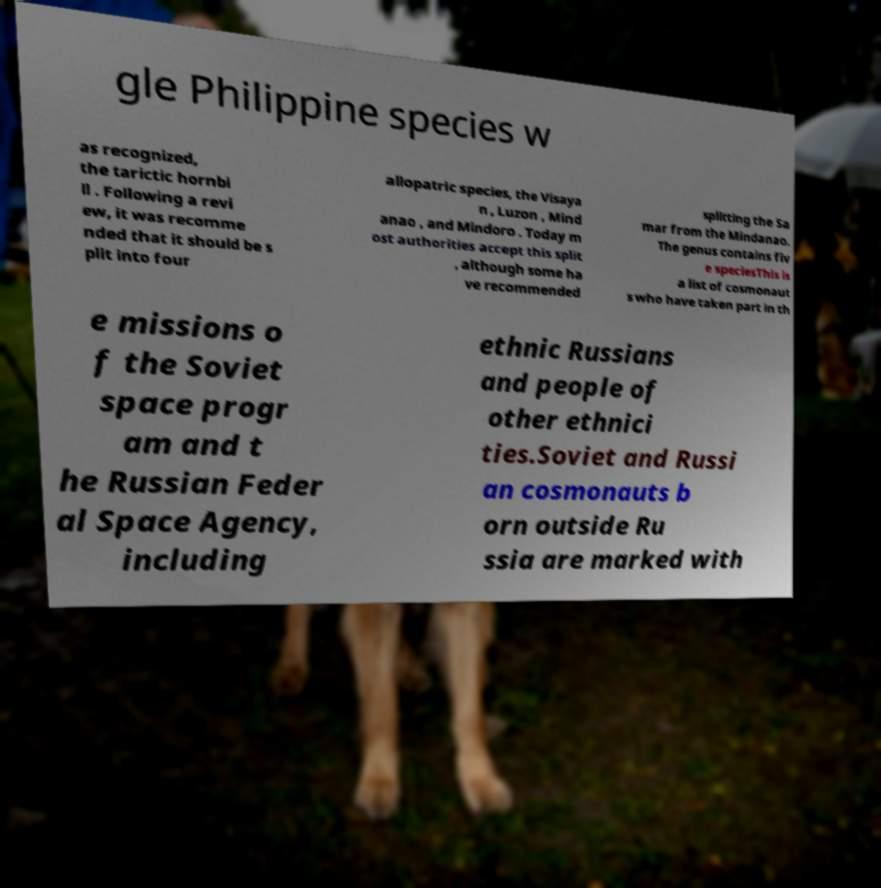Could you assist in decoding the text presented in this image and type it out clearly? gle Philippine species w as recognized, the tarictic hornbi ll . Following a revi ew, it was recomme nded that it should be s plit into four allopatric species, the Visaya n , Luzon , Mind anao , and Mindoro . Today m ost authorities accept this split , although some ha ve recommended splitting the Sa mar from the Mindanao. The genus contains fiv e speciesThis is a list of cosmonaut s who have taken part in th e missions o f the Soviet space progr am and t he Russian Feder al Space Agency, including ethnic Russians and people of other ethnici ties.Soviet and Russi an cosmonauts b orn outside Ru ssia are marked with 